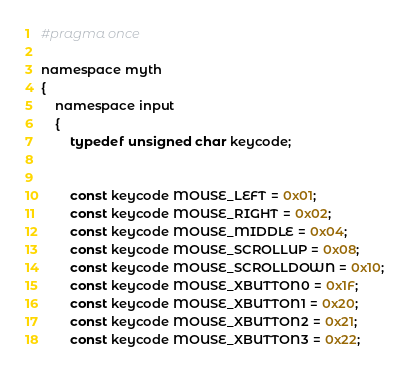<code> <loc_0><loc_0><loc_500><loc_500><_C_>

#pragma once

namespace myth
{
	namespace input
	{
		typedef unsigned char keycode;


		const keycode MOUSE_LEFT = 0x01;
		const keycode MOUSE_RIGHT = 0x02;
		const keycode MOUSE_MIDDLE = 0x04;
		const keycode MOUSE_SCROLLUP = 0x08;
		const keycode MOUSE_SCROLLDOWN = 0x10;
		const keycode MOUSE_XBUTTON0 = 0x1F;
		const keycode MOUSE_XBUTTON1 = 0x20;
		const keycode MOUSE_XBUTTON2 = 0x21;
		const keycode MOUSE_XBUTTON3 = 0x22;</code> 